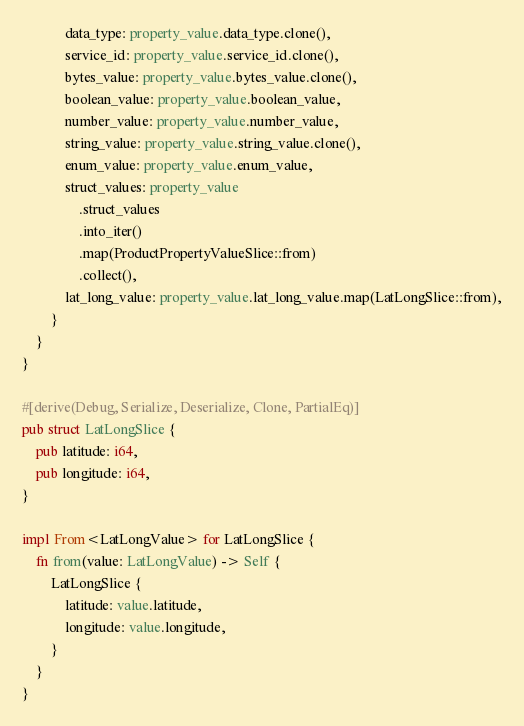Convert code to text. <code><loc_0><loc_0><loc_500><loc_500><_Rust_>            data_type: property_value.data_type.clone(),
            service_id: property_value.service_id.clone(),
            bytes_value: property_value.bytes_value.clone(),
            boolean_value: property_value.boolean_value,
            number_value: property_value.number_value,
            string_value: property_value.string_value.clone(),
            enum_value: property_value.enum_value,
            struct_values: property_value
                .struct_values
                .into_iter()
                .map(ProductPropertyValueSlice::from)
                .collect(),
            lat_long_value: property_value.lat_long_value.map(LatLongSlice::from),
        }
    }
}

#[derive(Debug, Serialize, Deserialize, Clone, PartialEq)]
pub struct LatLongSlice {
    pub latitude: i64,
    pub longitude: i64,
}

impl From<LatLongValue> for LatLongSlice {
    fn from(value: LatLongValue) -> Self {
        LatLongSlice {
            latitude: value.latitude,
            longitude: value.longitude,
        }
    }
}
</code> 